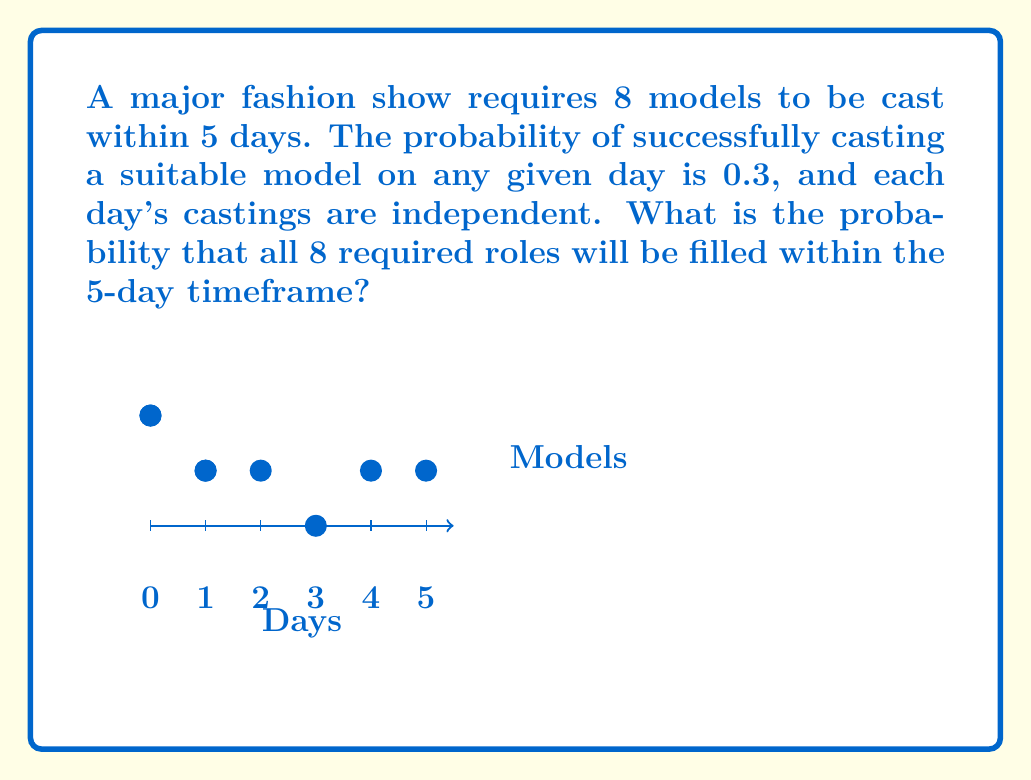Solve this math problem. Let's approach this step-by-step:

1) This scenario follows a binomial distribution, where we need to find the probability of at least 8 successes in 5 trials.

2) The probability of success on each day is 0.3, and the probability of failure is 0.7.

3) We can calculate this as 1 minus the probability of 7 or fewer successes:

   $$P(X \geq 8) = 1 - P(X \leq 7)$$

4) Using the binomial probability formula:

   $$P(X = k) = \binom{n}{k} p^k (1-p)^{n-k}$$

   Where $n = 5$ (days), $p = 0.3$ (probability of success), and $k = 0, 1, 2, ..., 7$

5) We need to sum this for $k = 0$ to $7$:

   $$P(X \leq 7) = \sum_{k=0}^{7} \binom{5}{k} (0.3)^k (0.7)^{5-k}$$

6) Calculating each term:

   $k = 0$: $\binom{5}{0} (0.3)^0 (0.7)^5 = 0.16807$
   $k = 1$: $\binom{5}{1} (0.3)^1 (0.7)^4 = 0.36015$
   $k = 2$: $\binom{5}{2} (0.3)^2 (0.7)^3 = 0.30870$
   $k = 3$: $\binom{5}{3} (0.3)^3 (0.7)^2 = 0.13230$
   $k = 4$: $\binom{5}{4} (0.3)^4 (0.7)^1 = 0.02835$
   $k = 5$: $\binom{5}{5} (0.3)^5 (0.7)^0 = 0.00243$

   (Note: $k = 6$ and $k = 7$ are impossible with only 5 days, so their probabilities are 0)

7) Sum these probabilities: $0.16807 + 0.36015 + 0.30870 + 0.13230 + 0.02835 + 0.00243 = 1$

8) Therefore, $P(X \leq 7) = 1$, and $P(X \geq 8) = 1 - 1 = 0$
Answer: 0 